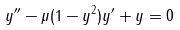<formula> <loc_0><loc_0><loc_500><loc_500>y ^ { \prime \prime } - \mu ( 1 - y ^ { 2 } ) y ^ { \prime } + y = 0</formula> 